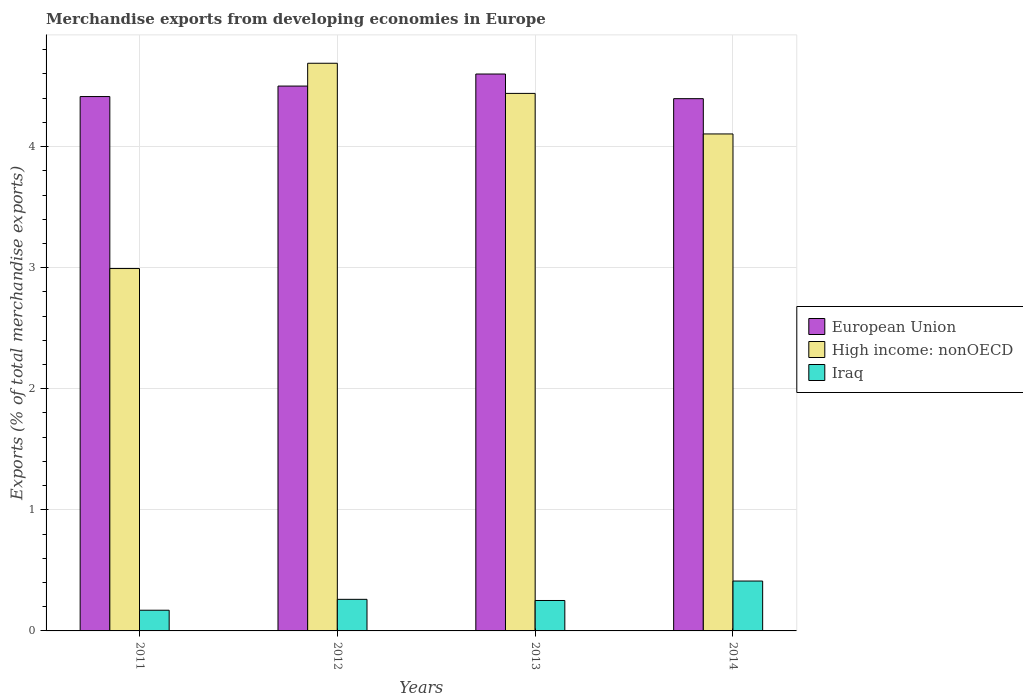How many different coloured bars are there?
Your answer should be compact. 3. Are the number of bars per tick equal to the number of legend labels?
Keep it short and to the point. Yes. How many bars are there on the 1st tick from the left?
Ensure brevity in your answer.  3. In how many cases, is the number of bars for a given year not equal to the number of legend labels?
Offer a very short reply. 0. What is the percentage of total merchandise exports in Iraq in 2013?
Your answer should be very brief. 0.25. Across all years, what is the maximum percentage of total merchandise exports in Iraq?
Your answer should be compact. 0.41. Across all years, what is the minimum percentage of total merchandise exports in European Union?
Your answer should be very brief. 4.4. In which year was the percentage of total merchandise exports in European Union maximum?
Your answer should be very brief. 2013. In which year was the percentage of total merchandise exports in European Union minimum?
Offer a terse response. 2014. What is the total percentage of total merchandise exports in European Union in the graph?
Your response must be concise. 17.91. What is the difference between the percentage of total merchandise exports in Iraq in 2012 and that in 2013?
Provide a short and direct response. 0.01. What is the difference between the percentage of total merchandise exports in High income: nonOECD in 2012 and the percentage of total merchandise exports in European Union in 2013?
Provide a short and direct response. 0.09. What is the average percentage of total merchandise exports in Iraq per year?
Offer a very short reply. 0.27. In the year 2014, what is the difference between the percentage of total merchandise exports in European Union and percentage of total merchandise exports in Iraq?
Your answer should be very brief. 3.98. What is the ratio of the percentage of total merchandise exports in Iraq in 2013 to that in 2014?
Ensure brevity in your answer.  0.61. What is the difference between the highest and the second highest percentage of total merchandise exports in Iraq?
Give a very brief answer. 0.15. What is the difference between the highest and the lowest percentage of total merchandise exports in Iraq?
Provide a short and direct response. 0.24. What does the 1st bar from the right in 2014 represents?
Your response must be concise. Iraq. Are the values on the major ticks of Y-axis written in scientific E-notation?
Make the answer very short. No. Does the graph contain any zero values?
Your answer should be very brief. No. How many legend labels are there?
Ensure brevity in your answer.  3. How are the legend labels stacked?
Provide a short and direct response. Vertical. What is the title of the graph?
Make the answer very short. Merchandise exports from developing economies in Europe. Does "Oman" appear as one of the legend labels in the graph?
Make the answer very short. No. What is the label or title of the Y-axis?
Make the answer very short. Exports (% of total merchandise exports). What is the Exports (% of total merchandise exports) in European Union in 2011?
Offer a terse response. 4.41. What is the Exports (% of total merchandise exports) of High income: nonOECD in 2011?
Your answer should be very brief. 2.99. What is the Exports (% of total merchandise exports) in Iraq in 2011?
Ensure brevity in your answer.  0.17. What is the Exports (% of total merchandise exports) in European Union in 2012?
Your answer should be very brief. 4.5. What is the Exports (% of total merchandise exports) in High income: nonOECD in 2012?
Offer a very short reply. 4.69. What is the Exports (% of total merchandise exports) of Iraq in 2012?
Provide a succinct answer. 0.26. What is the Exports (% of total merchandise exports) of European Union in 2013?
Keep it short and to the point. 4.6. What is the Exports (% of total merchandise exports) of High income: nonOECD in 2013?
Your response must be concise. 4.44. What is the Exports (% of total merchandise exports) in Iraq in 2013?
Make the answer very short. 0.25. What is the Exports (% of total merchandise exports) of European Union in 2014?
Make the answer very short. 4.4. What is the Exports (% of total merchandise exports) of High income: nonOECD in 2014?
Make the answer very short. 4.1. What is the Exports (% of total merchandise exports) in Iraq in 2014?
Give a very brief answer. 0.41. Across all years, what is the maximum Exports (% of total merchandise exports) in European Union?
Your response must be concise. 4.6. Across all years, what is the maximum Exports (% of total merchandise exports) in High income: nonOECD?
Offer a terse response. 4.69. Across all years, what is the maximum Exports (% of total merchandise exports) of Iraq?
Offer a terse response. 0.41. Across all years, what is the minimum Exports (% of total merchandise exports) of European Union?
Your answer should be compact. 4.4. Across all years, what is the minimum Exports (% of total merchandise exports) of High income: nonOECD?
Make the answer very short. 2.99. Across all years, what is the minimum Exports (% of total merchandise exports) in Iraq?
Your answer should be very brief. 0.17. What is the total Exports (% of total merchandise exports) in European Union in the graph?
Provide a succinct answer. 17.91. What is the total Exports (% of total merchandise exports) of High income: nonOECD in the graph?
Your answer should be compact. 16.22. What is the total Exports (% of total merchandise exports) of Iraq in the graph?
Give a very brief answer. 1.09. What is the difference between the Exports (% of total merchandise exports) of European Union in 2011 and that in 2012?
Your response must be concise. -0.09. What is the difference between the Exports (% of total merchandise exports) in High income: nonOECD in 2011 and that in 2012?
Your answer should be very brief. -1.7. What is the difference between the Exports (% of total merchandise exports) in Iraq in 2011 and that in 2012?
Give a very brief answer. -0.09. What is the difference between the Exports (% of total merchandise exports) of European Union in 2011 and that in 2013?
Provide a short and direct response. -0.19. What is the difference between the Exports (% of total merchandise exports) of High income: nonOECD in 2011 and that in 2013?
Offer a terse response. -1.45. What is the difference between the Exports (% of total merchandise exports) in Iraq in 2011 and that in 2013?
Provide a short and direct response. -0.08. What is the difference between the Exports (% of total merchandise exports) in European Union in 2011 and that in 2014?
Your response must be concise. 0.02. What is the difference between the Exports (% of total merchandise exports) of High income: nonOECD in 2011 and that in 2014?
Offer a terse response. -1.11. What is the difference between the Exports (% of total merchandise exports) in Iraq in 2011 and that in 2014?
Keep it short and to the point. -0.24. What is the difference between the Exports (% of total merchandise exports) of European Union in 2012 and that in 2013?
Offer a very short reply. -0.1. What is the difference between the Exports (% of total merchandise exports) of High income: nonOECD in 2012 and that in 2013?
Keep it short and to the point. 0.25. What is the difference between the Exports (% of total merchandise exports) in Iraq in 2012 and that in 2013?
Your answer should be compact. 0.01. What is the difference between the Exports (% of total merchandise exports) of European Union in 2012 and that in 2014?
Give a very brief answer. 0.1. What is the difference between the Exports (% of total merchandise exports) of High income: nonOECD in 2012 and that in 2014?
Keep it short and to the point. 0.58. What is the difference between the Exports (% of total merchandise exports) in Iraq in 2012 and that in 2014?
Make the answer very short. -0.15. What is the difference between the Exports (% of total merchandise exports) in European Union in 2013 and that in 2014?
Offer a very short reply. 0.2. What is the difference between the Exports (% of total merchandise exports) in High income: nonOECD in 2013 and that in 2014?
Your response must be concise. 0.33. What is the difference between the Exports (% of total merchandise exports) in Iraq in 2013 and that in 2014?
Give a very brief answer. -0.16. What is the difference between the Exports (% of total merchandise exports) of European Union in 2011 and the Exports (% of total merchandise exports) of High income: nonOECD in 2012?
Keep it short and to the point. -0.28. What is the difference between the Exports (% of total merchandise exports) of European Union in 2011 and the Exports (% of total merchandise exports) of Iraq in 2012?
Your answer should be very brief. 4.15. What is the difference between the Exports (% of total merchandise exports) of High income: nonOECD in 2011 and the Exports (% of total merchandise exports) of Iraq in 2012?
Ensure brevity in your answer.  2.73. What is the difference between the Exports (% of total merchandise exports) of European Union in 2011 and the Exports (% of total merchandise exports) of High income: nonOECD in 2013?
Your response must be concise. -0.03. What is the difference between the Exports (% of total merchandise exports) of European Union in 2011 and the Exports (% of total merchandise exports) of Iraq in 2013?
Make the answer very short. 4.16. What is the difference between the Exports (% of total merchandise exports) of High income: nonOECD in 2011 and the Exports (% of total merchandise exports) of Iraq in 2013?
Make the answer very short. 2.74. What is the difference between the Exports (% of total merchandise exports) of European Union in 2011 and the Exports (% of total merchandise exports) of High income: nonOECD in 2014?
Offer a very short reply. 0.31. What is the difference between the Exports (% of total merchandise exports) in European Union in 2011 and the Exports (% of total merchandise exports) in Iraq in 2014?
Ensure brevity in your answer.  4. What is the difference between the Exports (% of total merchandise exports) in High income: nonOECD in 2011 and the Exports (% of total merchandise exports) in Iraq in 2014?
Provide a succinct answer. 2.58. What is the difference between the Exports (% of total merchandise exports) of European Union in 2012 and the Exports (% of total merchandise exports) of High income: nonOECD in 2013?
Give a very brief answer. 0.06. What is the difference between the Exports (% of total merchandise exports) of European Union in 2012 and the Exports (% of total merchandise exports) of Iraq in 2013?
Make the answer very short. 4.25. What is the difference between the Exports (% of total merchandise exports) of High income: nonOECD in 2012 and the Exports (% of total merchandise exports) of Iraq in 2013?
Your response must be concise. 4.44. What is the difference between the Exports (% of total merchandise exports) of European Union in 2012 and the Exports (% of total merchandise exports) of High income: nonOECD in 2014?
Your response must be concise. 0.4. What is the difference between the Exports (% of total merchandise exports) of European Union in 2012 and the Exports (% of total merchandise exports) of Iraq in 2014?
Your answer should be very brief. 4.09. What is the difference between the Exports (% of total merchandise exports) in High income: nonOECD in 2012 and the Exports (% of total merchandise exports) in Iraq in 2014?
Give a very brief answer. 4.28. What is the difference between the Exports (% of total merchandise exports) in European Union in 2013 and the Exports (% of total merchandise exports) in High income: nonOECD in 2014?
Make the answer very short. 0.49. What is the difference between the Exports (% of total merchandise exports) in European Union in 2013 and the Exports (% of total merchandise exports) in Iraq in 2014?
Keep it short and to the point. 4.19. What is the difference between the Exports (% of total merchandise exports) in High income: nonOECD in 2013 and the Exports (% of total merchandise exports) in Iraq in 2014?
Ensure brevity in your answer.  4.03. What is the average Exports (% of total merchandise exports) in European Union per year?
Give a very brief answer. 4.48. What is the average Exports (% of total merchandise exports) in High income: nonOECD per year?
Provide a short and direct response. 4.06. What is the average Exports (% of total merchandise exports) in Iraq per year?
Ensure brevity in your answer.  0.27. In the year 2011, what is the difference between the Exports (% of total merchandise exports) in European Union and Exports (% of total merchandise exports) in High income: nonOECD?
Make the answer very short. 1.42. In the year 2011, what is the difference between the Exports (% of total merchandise exports) in European Union and Exports (% of total merchandise exports) in Iraq?
Give a very brief answer. 4.24. In the year 2011, what is the difference between the Exports (% of total merchandise exports) of High income: nonOECD and Exports (% of total merchandise exports) of Iraq?
Make the answer very short. 2.82. In the year 2012, what is the difference between the Exports (% of total merchandise exports) of European Union and Exports (% of total merchandise exports) of High income: nonOECD?
Make the answer very short. -0.19. In the year 2012, what is the difference between the Exports (% of total merchandise exports) in European Union and Exports (% of total merchandise exports) in Iraq?
Offer a terse response. 4.24. In the year 2012, what is the difference between the Exports (% of total merchandise exports) of High income: nonOECD and Exports (% of total merchandise exports) of Iraq?
Offer a very short reply. 4.43. In the year 2013, what is the difference between the Exports (% of total merchandise exports) of European Union and Exports (% of total merchandise exports) of High income: nonOECD?
Ensure brevity in your answer.  0.16. In the year 2013, what is the difference between the Exports (% of total merchandise exports) in European Union and Exports (% of total merchandise exports) in Iraq?
Give a very brief answer. 4.35. In the year 2013, what is the difference between the Exports (% of total merchandise exports) in High income: nonOECD and Exports (% of total merchandise exports) in Iraq?
Offer a very short reply. 4.19. In the year 2014, what is the difference between the Exports (% of total merchandise exports) in European Union and Exports (% of total merchandise exports) in High income: nonOECD?
Offer a terse response. 0.29. In the year 2014, what is the difference between the Exports (% of total merchandise exports) of European Union and Exports (% of total merchandise exports) of Iraq?
Keep it short and to the point. 3.98. In the year 2014, what is the difference between the Exports (% of total merchandise exports) in High income: nonOECD and Exports (% of total merchandise exports) in Iraq?
Provide a short and direct response. 3.69. What is the ratio of the Exports (% of total merchandise exports) in European Union in 2011 to that in 2012?
Make the answer very short. 0.98. What is the ratio of the Exports (% of total merchandise exports) in High income: nonOECD in 2011 to that in 2012?
Your answer should be very brief. 0.64. What is the ratio of the Exports (% of total merchandise exports) in Iraq in 2011 to that in 2012?
Ensure brevity in your answer.  0.66. What is the ratio of the Exports (% of total merchandise exports) of European Union in 2011 to that in 2013?
Make the answer very short. 0.96. What is the ratio of the Exports (% of total merchandise exports) in High income: nonOECD in 2011 to that in 2013?
Give a very brief answer. 0.67. What is the ratio of the Exports (% of total merchandise exports) in Iraq in 2011 to that in 2013?
Give a very brief answer. 0.68. What is the ratio of the Exports (% of total merchandise exports) of European Union in 2011 to that in 2014?
Give a very brief answer. 1. What is the ratio of the Exports (% of total merchandise exports) of High income: nonOECD in 2011 to that in 2014?
Give a very brief answer. 0.73. What is the ratio of the Exports (% of total merchandise exports) in Iraq in 2011 to that in 2014?
Keep it short and to the point. 0.41. What is the ratio of the Exports (% of total merchandise exports) in European Union in 2012 to that in 2013?
Your answer should be compact. 0.98. What is the ratio of the Exports (% of total merchandise exports) in High income: nonOECD in 2012 to that in 2013?
Your answer should be compact. 1.06. What is the ratio of the Exports (% of total merchandise exports) in Iraq in 2012 to that in 2013?
Your answer should be compact. 1.04. What is the ratio of the Exports (% of total merchandise exports) in European Union in 2012 to that in 2014?
Make the answer very short. 1.02. What is the ratio of the Exports (% of total merchandise exports) of High income: nonOECD in 2012 to that in 2014?
Your response must be concise. 1.14. What is the ratio of the Exports (% of total merchandise exports) of Iraq in 2012 to that in 2014?
Provide a short and direct response. 0.63. What is the ratio of the Exports (% of total merchandise exports) in European Union in 2013 to that in 2014?
Provide a short and direct response. 1.05. What is the ratio of the Exports (% of total merchandise exports) of High income: nonOECD in 2013 to that in 2014?
Offer a terse response. 1.08. What is the ratio of the Exports (% of total merchandise exports) in Iraq in 2013 to that in 2014?
Give a very brief answer. 0.61. What is the difference between the highest and the second highest Exports (% of total merchandise exports) of European Union?
Provide a succinct answer. 0.1. What is the difference between the highest and the second highest Exports (% of total merchandise exports) of High income: nonOECD?
Provide a short and direct response. 0.25. What is the difference between the highest and the second highest Exports (% of total merchandise exports) of Iraq?
Make the answer very short. 0.15. What is the difference between the highest and the lowest Exports (% of total merchandise exports) of European Union?
Provide a succinct answer. 0.2. What is the difference between the highest and the lowest Exports (% of total merchandise exports) of High income: nonOECD?
Provide a succinct answer. 1.7. What is the difference between the highest and the lowest Exports (% of total merchandise exports) of Iraq?
Your answer should be compact. 0.24. 